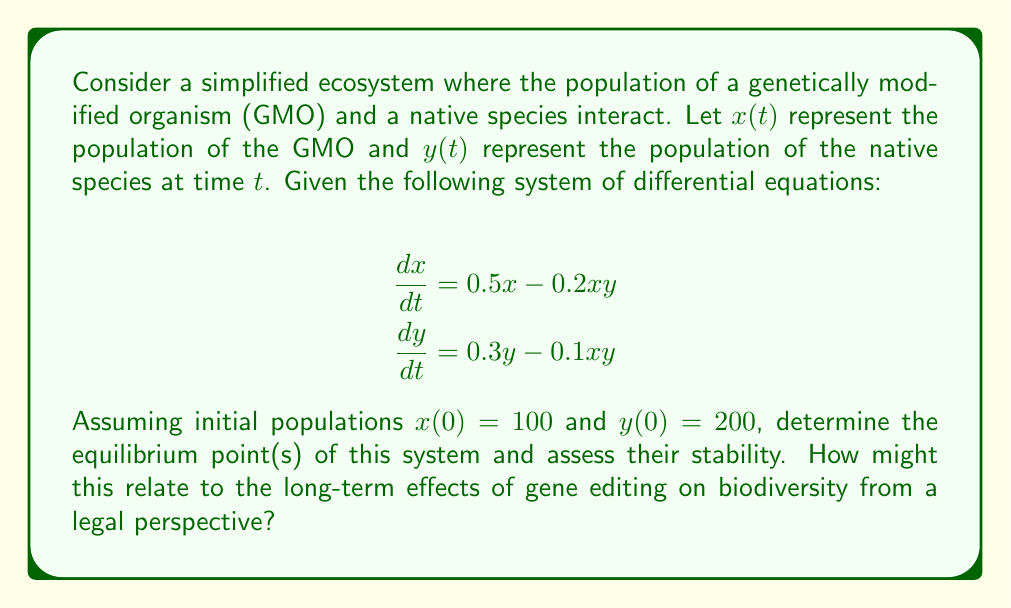Solve this math problem. To solve this problem, we'll follow these steps:

1) Find the equilibrium points by setting both equations to zero:

   $$0.5x - 0.2xy = 0$$
   $$0.3y - 0.1xy = 0$$

2) Solve these equations:
   From the first equation:
   $$x(0.5 - 0.2y) = 0$$
   So either $x = 0$ or $y = 2.5$

   From the second equation:
   $$y(0.3 - 0.1x) = 0$$
   So either $y = 0$ or $x = 3$

3) Combining these results, we get three equilibrium points:
   $(0, 0)$, $(3, 0)$, and $(3, 2.5)$

4) To assess stability, we need to calculate the Jacobian matrix:

   $$J = \begin{bmatrix}
   \frac{\partial}{\partial x}(0.5x - 0.2xy) & \frac{\partial}{\partial y}(0.5x - 0.2xy) \\
   \frac{\partial}{\partial x}(0.3y - 0.1xy) & \frac{\partial}{\partial y}(0.3y - 0.1xy)
   \end{bmatrix}$$

   $$J = \begin{bmatrix}
   0.5 - 0.2y & -0.2x \\
   -0.1y & 0.3 - 0.1x
   \end{bmatrix}$$

5) Evaluate the Jacobian at each equilibrium point and find its eigenvalues:

   At $(0, 0)$: $J = \begin{bmatrix} 0.5 & 0 \\ 0 & 0.3 \end{bmatrix}$
   Eigenvalues: 0.5 and 0.3 (both positive, unstable)

   At $(3, 0)$: $J = \begin{bmatrix} 0.5 & -0.6 \\ 0 & -0.3 \end{bmatrix}$
   Eigenvalues: 0.5 and -0.3 (one positive, one negative, unstable)

   At $(3, 2.5)$: $J = \begin{bmatrix} 0 & -0.6 \\ -0.25 & 0 \end{bmatrix}$
   Eigenvalues: $\pm 0.387i$ (purely imaginary, center)

6) The equilibrium point $(3, 2.5)$ represents coexistence of both species. It's neutrally stable, meaning small perturbations will cause oscillations around this point.

From a legal perspective, this model suggests that introducing GMOs could lead to a new equilibrium where both species coexist, but the stability is delicate. This highlights the need for careful regulation and monitoring of gene editing technologies to ensure biodiversity is maintained.
Answer: Equilibrium points: $(0, 0)$, $(3, 0)$, $(3, 2.5)$. $(3, 2.5)$ is neutrally stable, others unstable. Legally, suggests need for careful GMO regulation. 